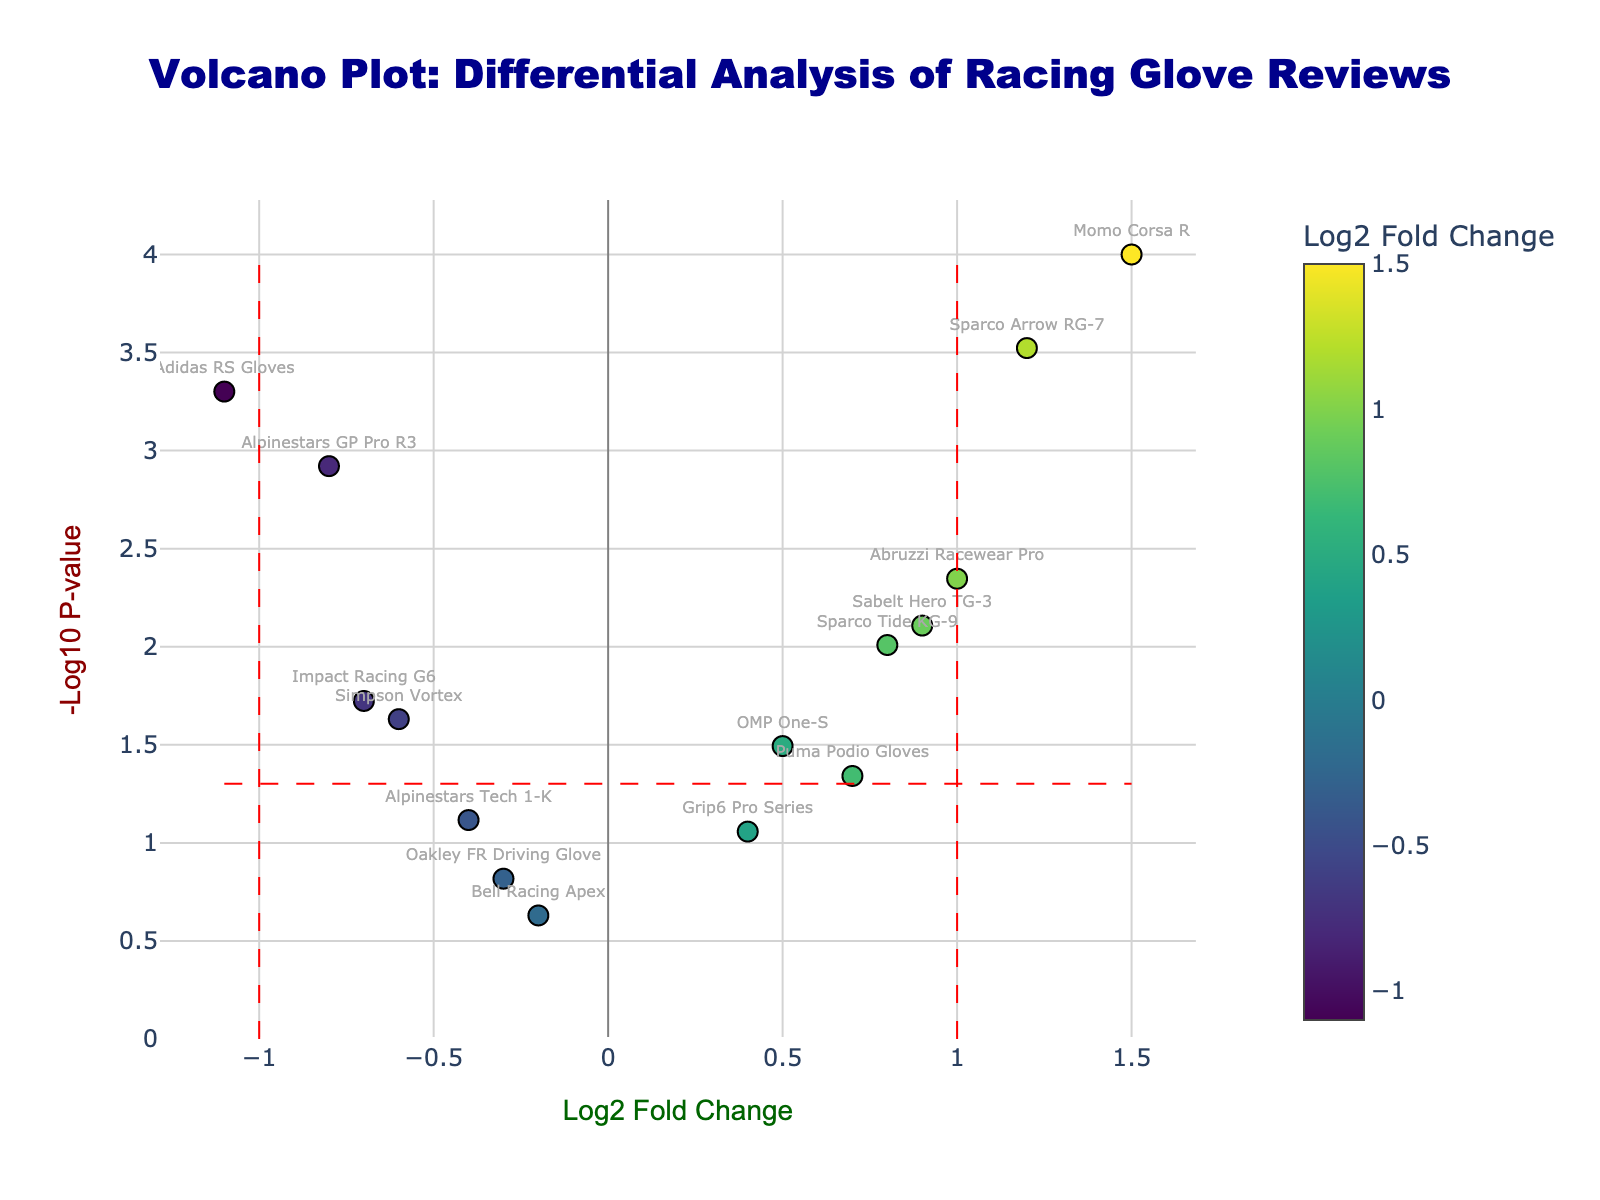How many racing glove models have a log2 fold change greater than 1? We count the data points with log2 fold change values greater than 1: Sparco Arrow RG-7 and Momo Corsa R.
Answer: 2 Which racing glove model has the highest -log10 p-value? The point highest on the y-axis (-log10 p-value) is Momo Corsa R with approximately 4.
Answer: Momo Corsa R What is the log2 fold change and p-value for Adidas RS Gloves? The point corresponding to Adidas RS Gloves is marked by its coordinates on the plot: Log2 fold change = -1.1 and p-value = 0.0005.
Answer: -1.1 and 0.0005 Are there any models with a p-value higher than 0.1? Points with a -log10 p-value less than -log10(0.1) (log10 p around 1) have higher p-values. The models are Oakley FR Driving Glove, Bell Racing Apex, and Alpinestars Tech 1-K.
Answer: Yes Which racing glove model has a log2 fold change closest to zero? We look for the point nearest the vertical line at zero on the x-axis, which is the Bell Racing Apex with a log2 fold change of -0.2.
Answer: Bell Racing Apex Are there any products with significant changes both in fold change and p-value? Significant changes are generally found at points far from both axes, and above the red dashed horizontal line (-log10(0.05)) and outside the vertical lines (log2 fold change < -1 or > 1): Sparco Arrow RG-7, Adidas RS Gloves, Momo Corsa R, Abruzzi Racewear Pro, and Sabelt Hero TG-3.
Answer: Yes What is the log2 fold change and -log10 p-value range for all glove models? The lowest and highest values for both axes: log2 fold change ranges from -1.1 (Adidas RS Gloves) to 1.5 (Momo Corsa R), and -log10 p-value ranges from approximately 0.63 (Bell Racing Apex) to 4 (Momo Corsa R).
Answer: -1.1 to 1.5 (log2 fold change), 0.63 to 4 (-log10 p-value) Which products lie between the log2 fold change values of -0.5 and 0.5? Points within x-values from -0.5 to 0.5: OMP One-S, Oakley FR Driving Glove, Bell Racing Apex, and Grip6 Pro Series.
Answer: OMP One-S, Oakley FR Driving Glove, Bell Racing Apex, Grip6 Pro Series What is the impact of Sparco Arrow RG-7 according to the plot? We see the point labeled Sparco Arrow RG-7, which is high on the y-axis (significant p-value) and to the right of the x-axis (> 1 log2 fold change), indicating a substantial positive fold change and significant result.
Answer: Substantially positive and significant 